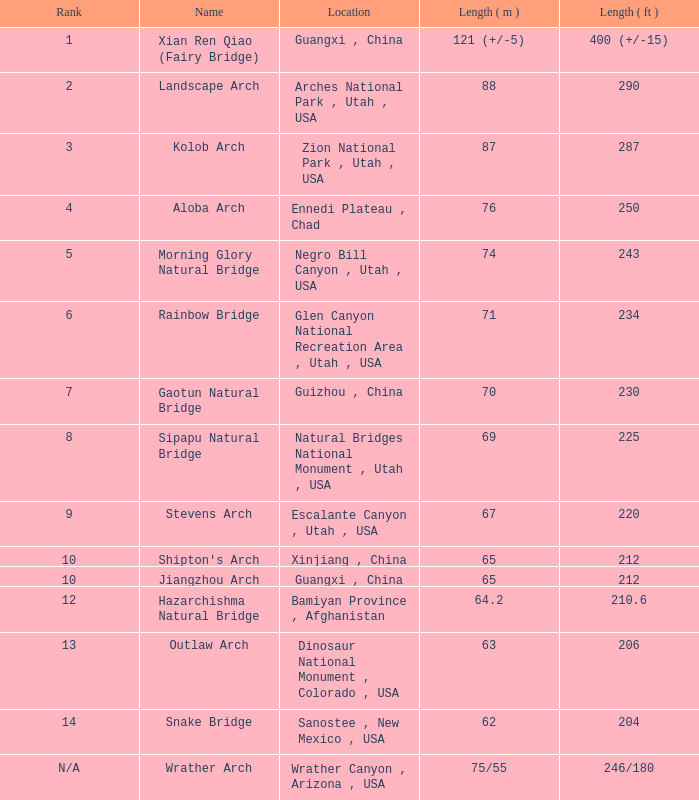Where is the longest arch with a length in meters of 64.2? Bamiyan Province , Afghanistan. 